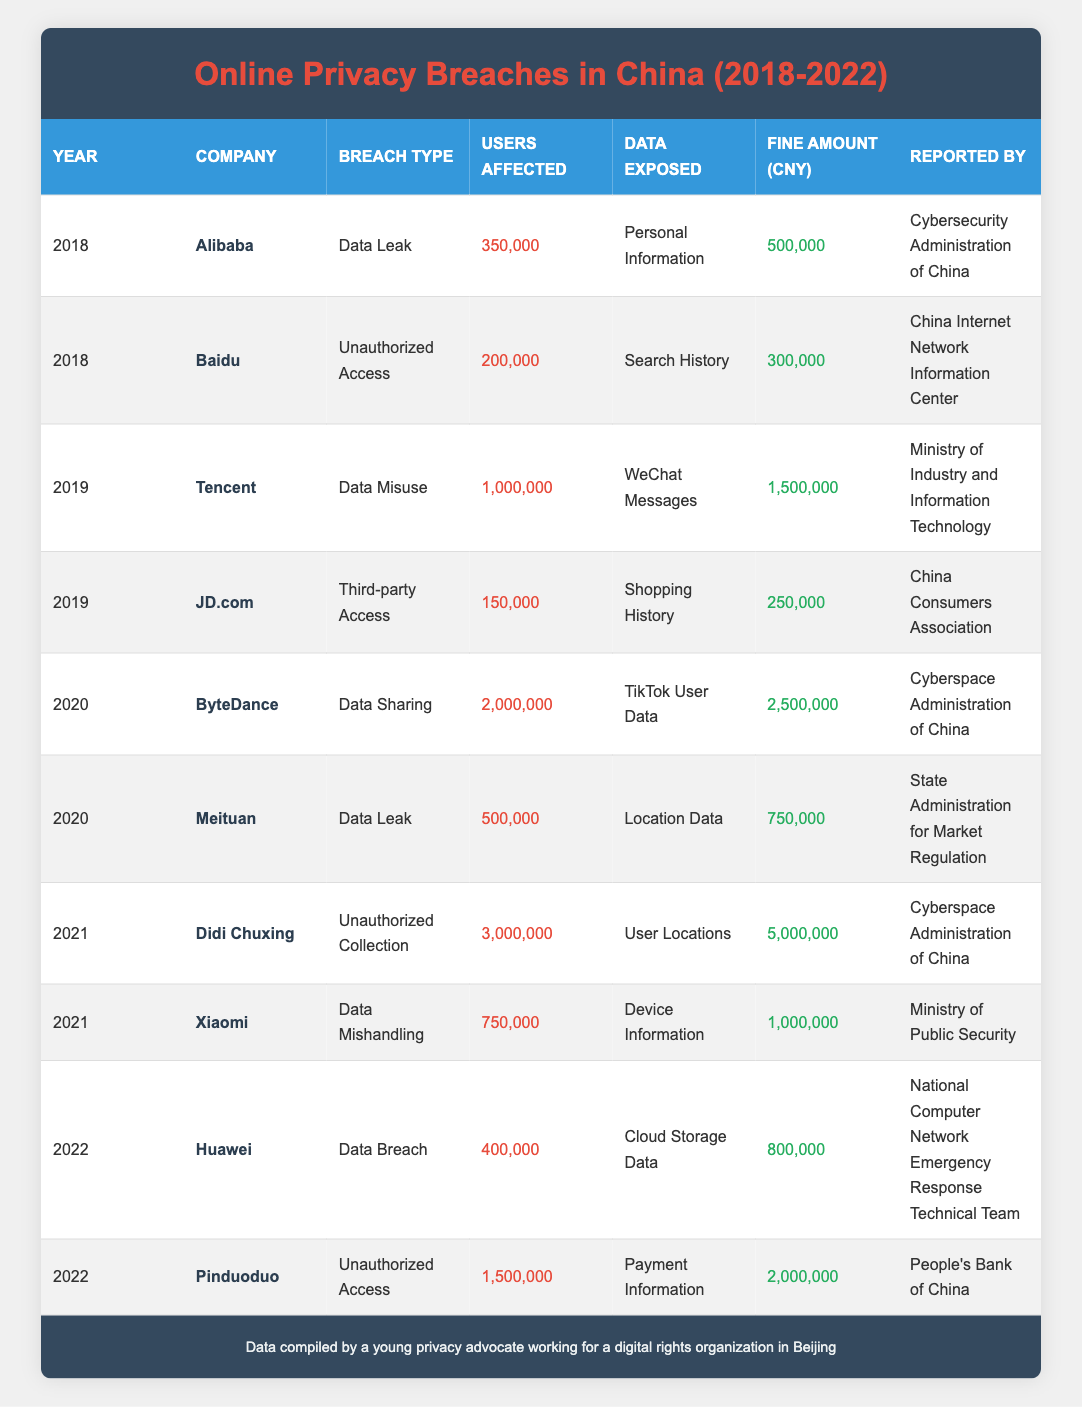What is the total number of users affected by data breaches in 2020? For 2020, there are two breaches: ByteDance affected 2,000,000 users and Meituan affected 500,000 users. To find the total, we sum these two values: 2,000,000 + 500,000 = 2,500,000.
Answer: 2,500,000 Which company reported the highest fine amount and what was the amount? Reviewing the fine amounts for each company, Didi Chuxing in 2021 has the highest fine of 5,000,000.
Answer: Didi Chuxing; 5,000,000 How many total users were affected by breaches listed in 2018? In 2018, Alibaba affected 350,000 users and Baidu affected 200,000 users. The total is 350,000 + 200,000 = 550,000 users.
Answer: 550,000 Did any company accumulate a fine amount greater than 1,000,000 in 2019? In 2019, Tencent accumulated a fine of 1,500,000 and JD.com had 250,000. Since 1,500,000 is greater than 1,000,000, the answer is yes.
Answer: Yes What data type was the most commonly exposed in breaches from 2018 to 2022? Analyzing the data exposed in the breaches: Personal Information (1), Search History (1), WeChat Messages (1), Shopping History (1), TikTok User Data (1), Location Data (1), User Locations (1), Device Information (1), Cloud Storage Data (1), and Payment Information (1). Each category appears only once, so there is no most common category.
Answer: None Which breach type was reported by the Ministry of Public Security? The only breach reported by the Ministry of Public Security was "Data Mishandling" incident by Xiaomi in 2021.
Answer: Data Mishandling How many total breaches were reported in 2022? There are two entries for the year 2022: Huawei and Pinduoduo, indicating there were 2 breaches reported that year.
Answer: 2 Was the data exposed more frequently related to user locations than personal information from 2018 to 2022? The breaches for personal information were 1 (Alibaba), while user location data appears twice (Didi Chuxing and Meituan). Since there are two incidents concerning user locations, the answer is yes.
Answer: Yes 